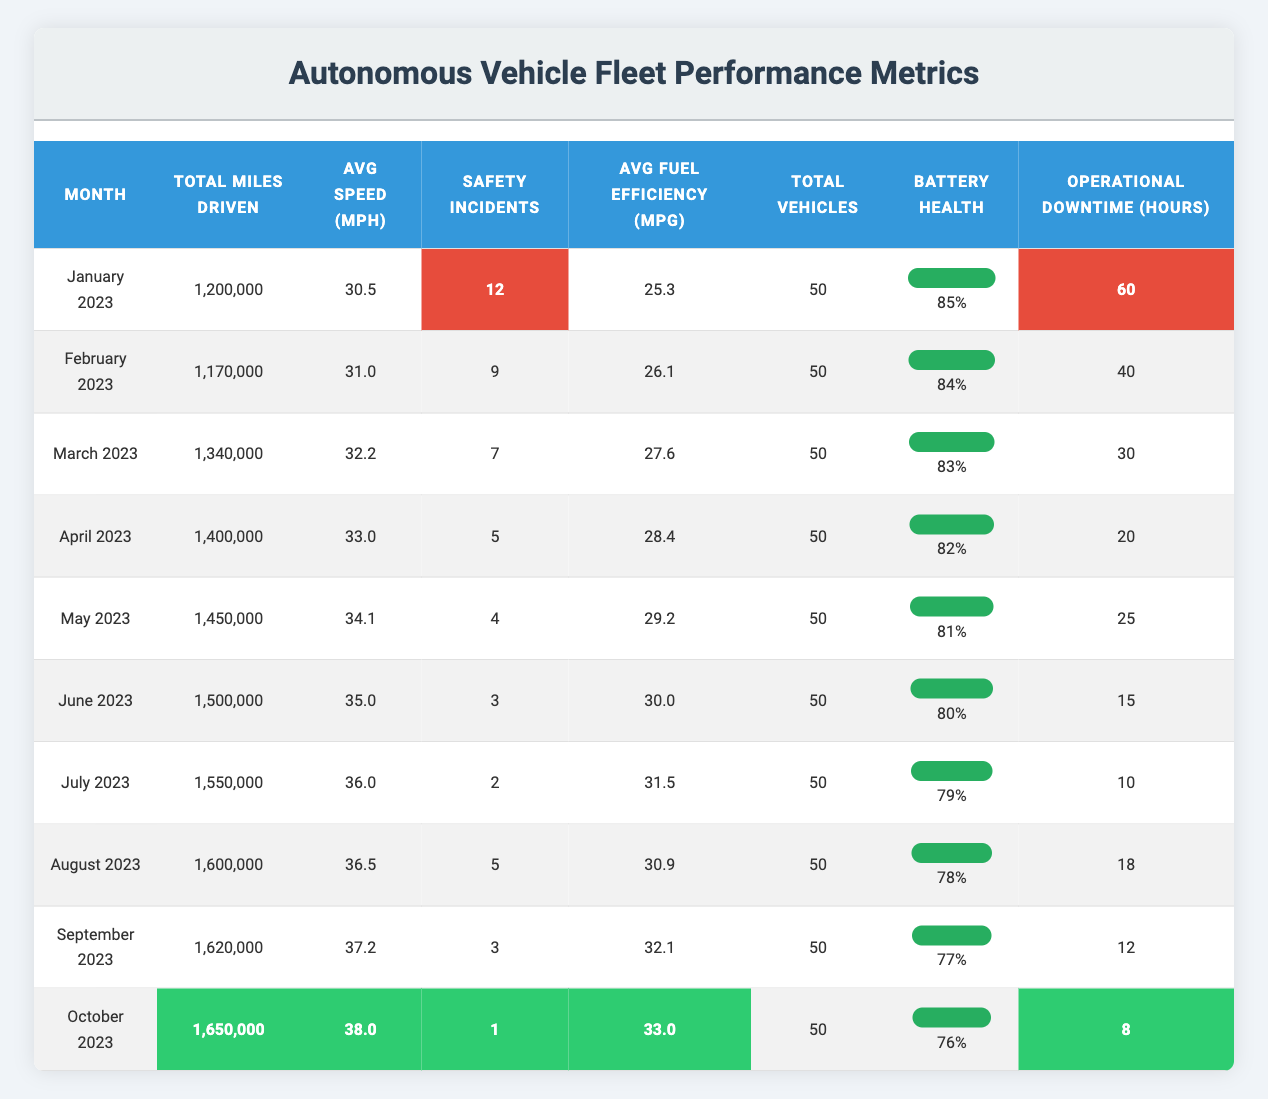What was the total miles driven in March 2023? The table shows that in March 2023, the total miles driven was recorded as 1,340,000.
Answer: 1,340,000 How many safety incidents occurred in July 2023? The table indicates that there were 2 safety incidents reported in July 2023.
Answer: 2 What is the average speed in August 2023? According to the table, the average speed in August 2023 was 36.5 mph.
Answer: 36.5 What was the average fuel efficiency for the fleet over these ten months? To find the average fuel efficiency, sum the average fuel efficiencies from each month: (25.3 + 26.1 + 27.6 + 28.4 + 29.2 + 30.0 + 31.5 + 30.9 + 32.1 + 33.0) =  30.01; then divide by 10 (the number of months), which gives us 300.1/10 = 30.01 mpg.
Answer: 30.01 Was there an increase or decrease in operational downtime from January to October 2023? In January 2023, operational downtime was 60 hours, and in October 2023, it decreased to 8 hours. The difference is 60 - 8 = 52 hours, indicating a decrease.
Answer: Decrease What was the trend in safety incidents from January to October 2023? The safety incidents decreased each month from January (12 incidents) to October (1 incident); the months are: 12, 9, 7, 5, 4, 3, 2, 5, 3, and 1. Overall, the trend shows a reduction over the months.
Answer: Decrease Which month had the highest average fuel efficiency? The highest average fuel efficiency was reported in October 2023, with an average of 33.0 mpg.
Answer: October 2023 What is the relationship between total miles driven and battery health from January to October 2023? Observing the data, total miles driven increased each month while battery health percentage decreased from 85% in January to 76% in October. Therefore, as the total miles driven rises, battery health tends to decrease.
Answer: Inverse relationship How many operational downtime hours did the fleet experience in total from January to October 2023? Summing the operational downtime hours: 60 + 40 + 30 + 20 + 25 + 15 + 10 + 18 + 12 + 8 =  228 hours total downtime from January to October.
Answer: 228 hours What was the change in the average speed from January to October 2023? The average speed increased from 30.5 mph in January to 38.0 mph in October, resulting in a change of 38.0 - 30.5 = 7.5 mph.
Answer: 7.5 mph increase 